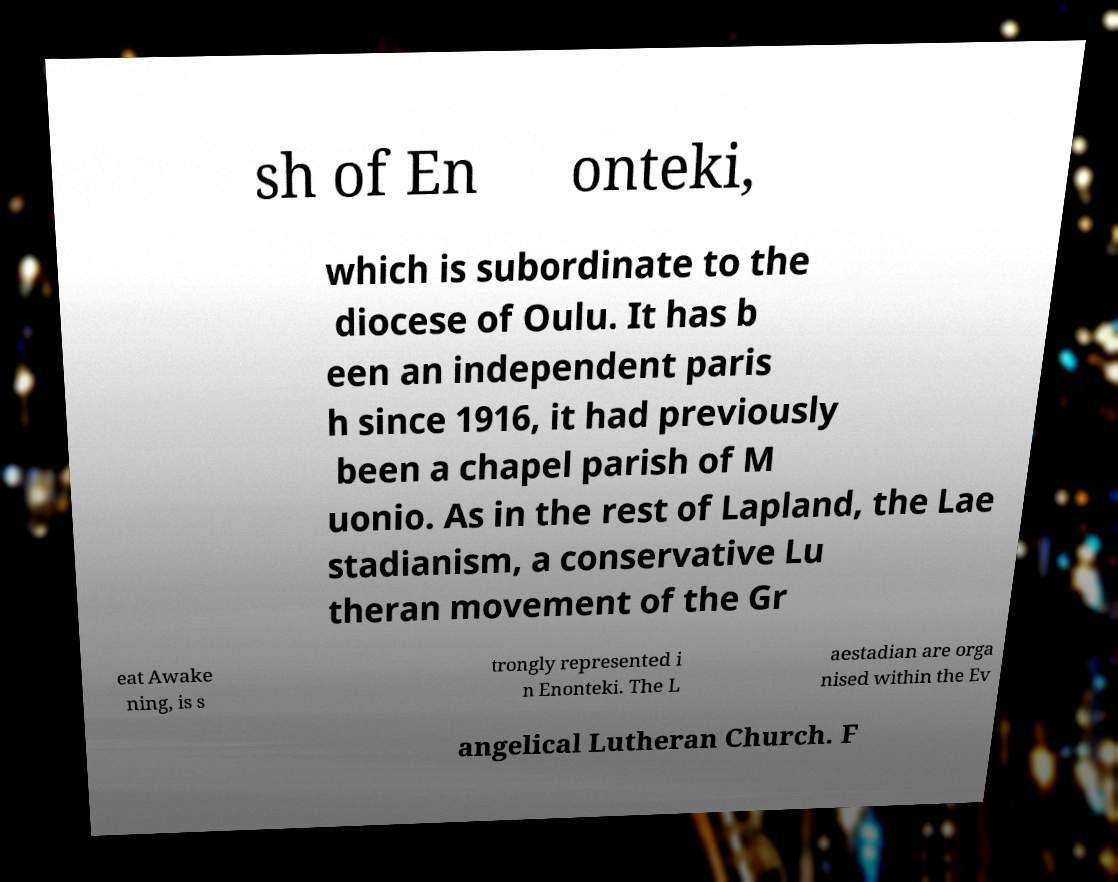Can you read and provide the text displayed in the image?This photo seems to have some interesting text. Can you extract and type it out for me? sh of En onteki, which is subordinate to the diocese of Oulu. It has b een an independent paris h since 1916, it had previously been a chapel parish of M uonio. As in the rest of Lapland, the Lae stadianism, a conservative Lu theran movement of the Gr eat Awake ning, is s trongly represented i n Enonteki. The L aestadian are orga nised within the Ev angelical Lutheran Church. F 